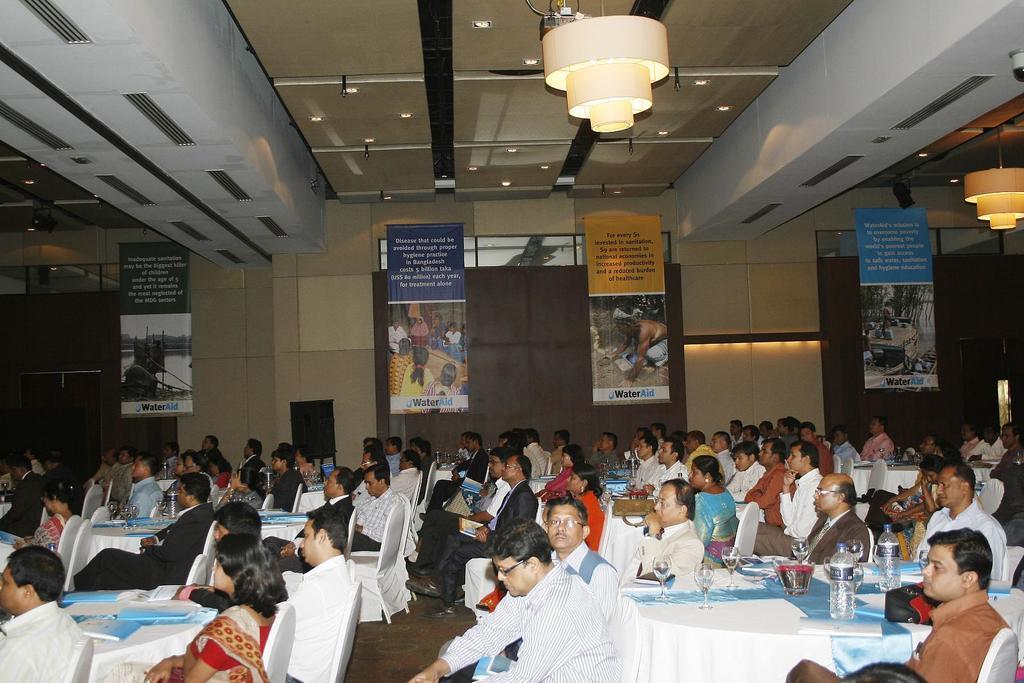How would you summarize this image in a sentence or two? Lights are attached to the rooftop. Here we can see banners. People are sitting on chairs. In-front of them there are tables with glasses, bottles and books. 